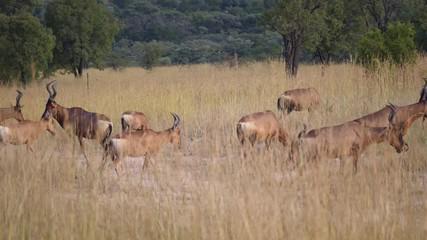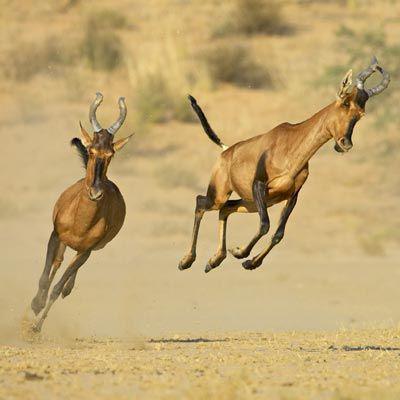The first image is the image on the left, the second image is the image on the right. Examine the images to the left and right. Is the description "An image includes a horned animal that is bounding with front legs fully off the ground." accurate? Answer yes or no. Yes. The first image is the image on the left, the second image is the image on the right. Assess this claim about the two images: "At least one antelope has its front legs int he air.". Correct or not? Answer yes or no. Yes. 